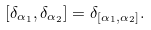Convert formula to latex. <formula><loc_0><loc_0><loc_500><loc_500>[ \delta _ { \alpha _ { 1 } } , \delta _ { \alpha _ { 2 } } ] = \delta _ { [ \alpha _ { 1 } , \alpha _ { 2 } ] } .</formula> 